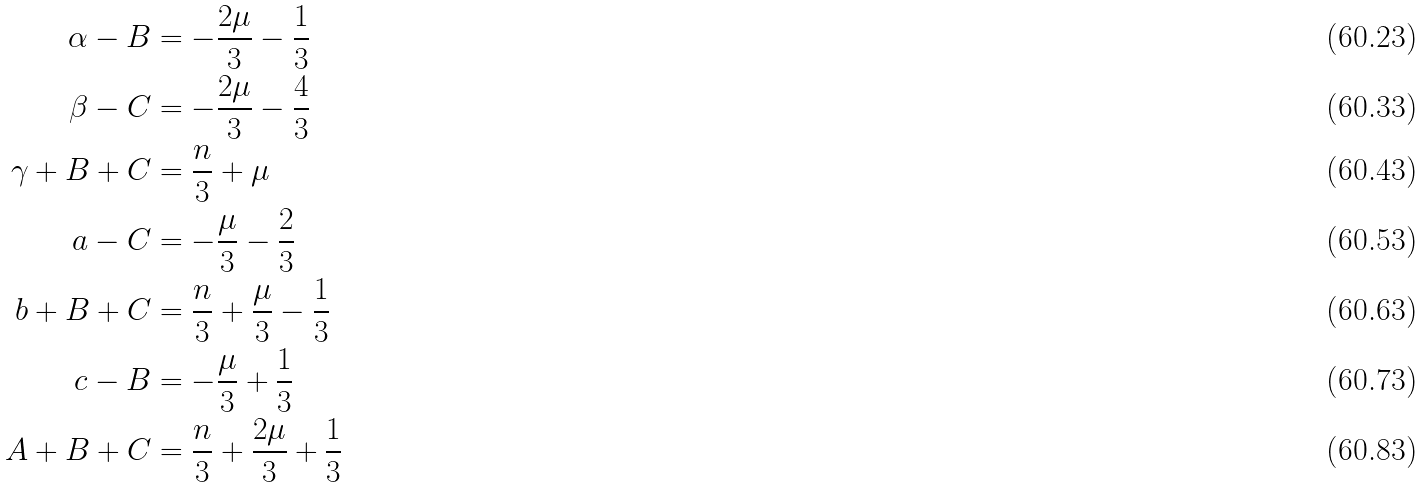<formula> <loc_0><loc_0><loc_500><loc_500>\alpha - B & = - \frac { 2 \mu } { 3 } - \frac { 1 } { 3 } \\ \beta - C & = - \frac { 2 \mu } { 3 } - \frac { 4 } { 3 } \\ \gamma + B + C & = \frac { n } { 3 } + \mu \\ a - C & = - \frac { \mu } { 3 } - \frac { 2 } { 3 } \\ b + B + C & = \frac { n } { 3 } + \frac { \mu } { 3 } - \frac { 1 } { 3 } \\ c - B & = - \frac { \mu } { 3 } + \frac { 1 } { 3 } \\ A + B + C & = \frac { n } { 3 } + \frac { 2 \mu } { 3 } + \frac { 1 } { 3 }</formula> 